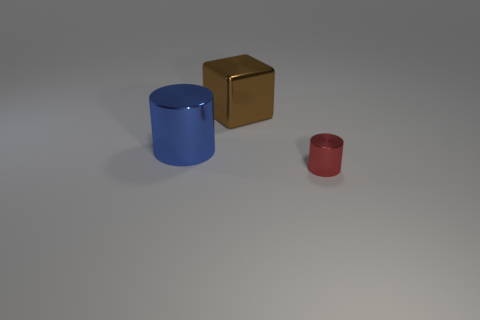Is there any other thing that has the same size as the red object?
Offer a very short reply. No. Are there any other things that have the same material as the cube?
Make the answer very short. Yes. Do the brown block and the metallic thing to the right of the large brown shiny object have the same size?
Ensure brevity in your answer.  No. What number of things are objects that are left of the red object or things that are on the right side of the big blue metallic object?
Your answer should be very brief. 3. The cylinder that is on the left side of the red cylinder is what color?
Offer a very short reply. Blue. There is a metal cylinder that is to the left of the red shiny object; are there any shiny objects to the right of it?
Your answer should be very brief. Yes. Is the number of blue rubber cubes less than the number of blocks?
Ensure brevity in your answer.  Yes. What is the object that is left of the large metallic object that is to the right of the big blue shiny thing made of?
Your answer should be compact. Metal. Is the size of the blue cylinder the same as the red cylinder?
Your answer should be compact. No. How many objects are either brown cubes or small brown spheres?
Offer a very short reply. 1. 